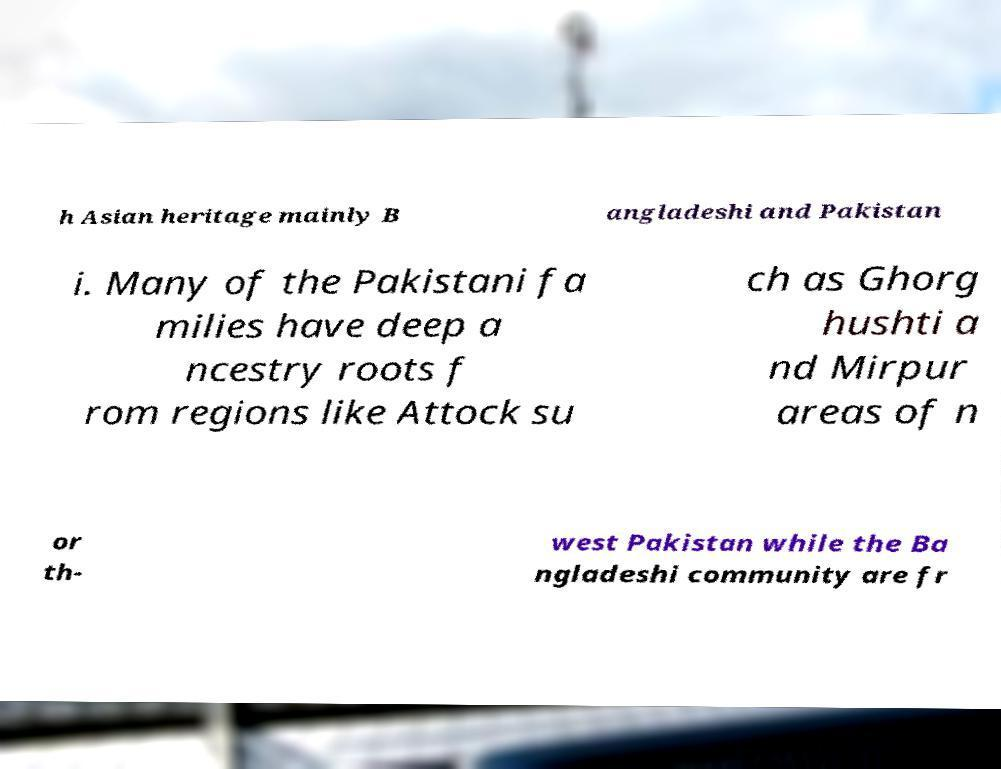For documentation purposes, I need the text within this image transcribed. Could you provide that? h Asian heritage mainly B angladeshi and Pakistan i. Many of the Pakistani fa milies have deep a ncestry roots f rom regions like Attock su ch as Ghorg hushti a nd Mirpur areas of n or th- west Pakistan while the Ba ngladeshi community are fr 